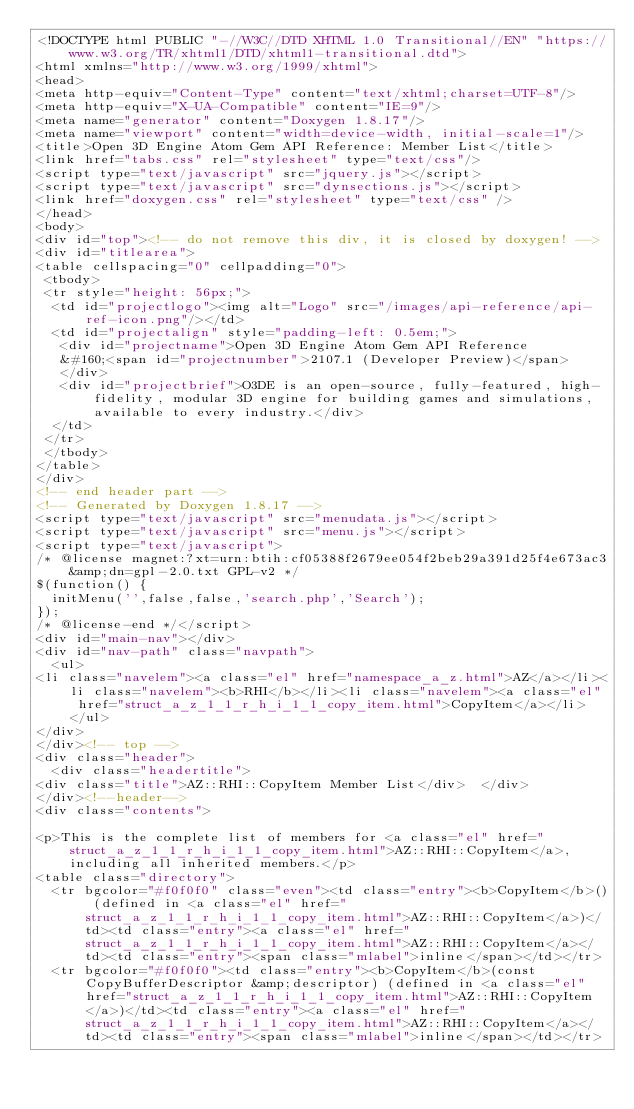<code> <loc_0><loc_0><loc_500><loc_500><_HTML_><!DOCTYPE html PUBLIC "-//W3C//DTD XHTML 1.0 Transitional//EN" "https://www.w3.org/TR/xhtml1/DTD/xhtml1-transitional.dtd">
<html xmlns="http://www.w3.org/1999/xhtml">
<head>
<meta http-equiv="Content-Type" content="text/xhtml;charset=UTF-8"/>
<meta http-equiv="X-UA-Compatible" content="IE=9"/>
<meta name="generator" content="Doxygen 1.8.17"/>
<meta name="viewport" content="width=device-width, initial-scale=1"/>
<title>Open 3D Engine Atom Gem API Reference: Member List</title>
<link href="tabs.css" rel="stylesheet" type="text/css"/>
<script type="text/javascript" src="jquery.js"></script>
<script type="text/javascript" src="dynsections.js"></script>
<link href="doxygen.css" rel="stylesheet" type="text/css" />
</head>
<body>
<div id="top"><!-- do not remove this div, it is closed by doxygen! -->
<div id="titlearea">
<table cellspacing="0" cellpadding="0">
 <tbody>
 <tr style="height: 56px;">
  <td id="projectlogo"><img alt="Logo" src="/images/api-reference/api-ref-icon.png"/></td>
  <td id="projectalign" style="padding-left: 0.5em;">
   <div id="projectname">Open 3D Engine Atom Gem API Reference
   &#160;<span id="projectnumber">2107.1 (Developer Preview)</span>
   </div>
   <div id="projectbrief">O3DE is an open-source, fully-featured, high-fidelity, modular 3D engine for building games and simulations, available to every industry.</div>
  </td>
 </tr>
 </tbody>
</table>
</div>
<!-- end header part -->
<!-- Generated by Doxygen 1.8.17 -->
<script type="text/javascript" src="menudata.js"></script>
<script type="text/javascript" src="menu.js"></script>
<script type="text/javascript">
/* @license magnet:?xt=urn:btih:cf05388f2679ee054f2beb29a391d25f4e673ac3&amp;dn=gpl-2.0.txt GPL-v2 */
$(function() {
  initMenu('',false,false,'search.php','Search');
});
/* @license-end */</script>
<div id="main-nav"></div>
<div id="nav-path" class="navpath">
  <ul>
<li class="navelem"><a class="el" href="namespace_a_z.html">AZ</a></li><li class="navelem"><b>RHI</b></li><li class="navelem"><a class="el" href="struct_a_z_1_1_r_h_i_1_1_copy_item.html">CopyItem</a></li>  </ul>
</div>
</div><!-- top -->
<div class="header">
  <div class="headertitle">
<div class="title">AZ::RHI::CopyItem Member List</div>  </div>
</div><!--header-->
<div class="contents">

<p>This is the complete list of members for <a class="el" href="struct_a_z_1_1_r_h_i_1_1_copy_item.html">AZ::RHI::CopyItem</a>, including all inherited members.</p>
<table class="directory">
  <tr bgcolor="#f0f0f0" class="even"><td class="entry"><b>CopyItem</b>() (defined in <a class="el" href="struct_a_z_1_1_r_h_i_1_1_copy_item.html">AZ::RHI::CopyItem</a>)</td><td class="entry"><a class="el" href="struct_a_z_1_1_r_h_i_1_1_copy_item.html">AZ::RHI::CopyItem</a></td><td class="entry"><span class="mlabel">inline</span></td></tr>
  <tr bgcolor="#f0f0f0"><td class="entry"><b>CopyItem</b>(const CopyBufferDescriptor &amp;descriptor) (defined in <a class="el" href="struct_a_z_1_1_r_h_i_1_1_copy_item.html">AZ::RHI::CopyItem</a>)</td><td class="entry"><a class="el" href="struct_a_z_1_1_r_h_i_1_1_copy_item.html">AZ::RHI::CopyItem</a></td><td class="entry"><span class="mlabel">inline</span></td></tr></code> 